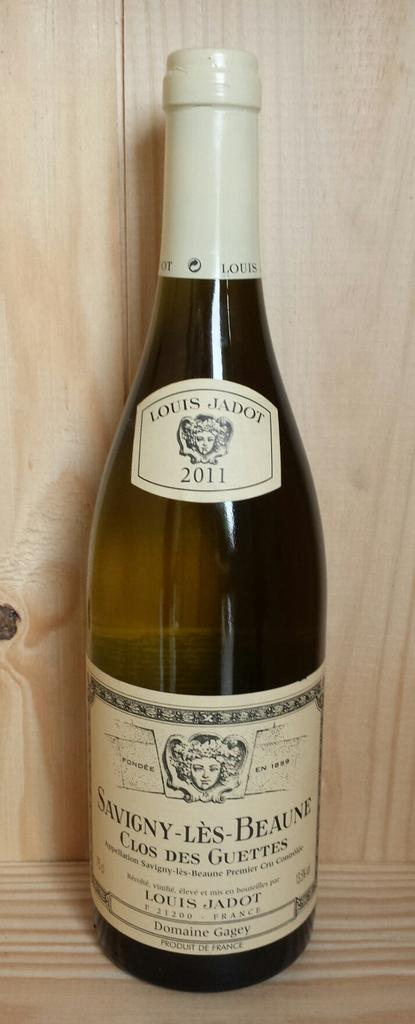<image>
Share a concise interpretation of the image provided. A bottle of Louis Jadot wine that is on a shelf. 